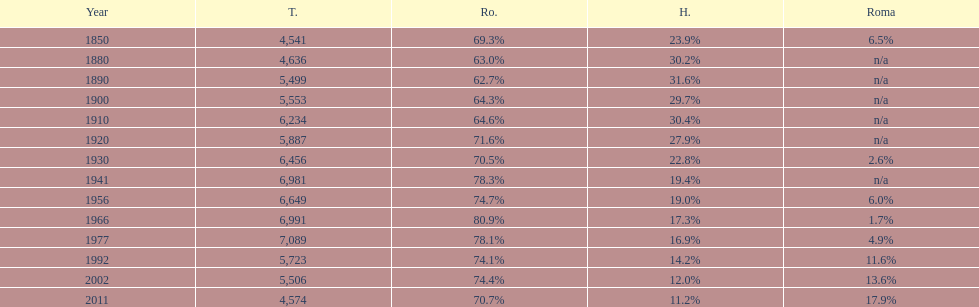Give me the full table as a dictionary. {'header': ['Year', 'T.', 'Ro.', 'H.', 'Roma'], 'rows': [['1850', '4,541', '69.3%', '23.9%', '6.5%'], ['1880', '4,636', '63.0%', '30.2%', 'n/a'], ['1890', '5,499', '62.7%', '31.6%', 'n/a'], ['1900', '5,553', '64.3%', '29.7%', 'n/a'], ['1910', '6,234', '64.6%', '30.4%', 'n/a'], ['1920', '5,887', '71.6%', '27.9%', 'n/a'], ['1930', '6,456', '70.5%', '22.8%', '2.6%'], ['1941', '6,981', '78.3%', '19.4%', 'n/a'], ['1956', '6,649', '74.7%', '19.0%', '6.0%'], ['1966', '6,991', '80.9%', '17.3%', '1.7%'], ['1977', '7,089', '78.1%', '16.9%', '4.9%'], ['1992', '5,723', '74.1%', '14.2%', '11.6%'], ['2002', '5,506', '74.4%', '12.0%', '13.6%'], ['2011', '4,574', '70.7%', '11.2%', '17.9%']]} In the most recent year displayed on this chart, what proportion of the population consisted of romanians? 70.7%. 